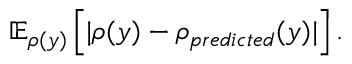Convert formula to latex. <formula><loc_0><loc_0><loc_500><loc_500>\mathbb { E } _ { \rho ( y ) } \left [ | \rho ( y ) - \rho _ { p r e d i c t e d } ( y ) | \right ] .</formula> 